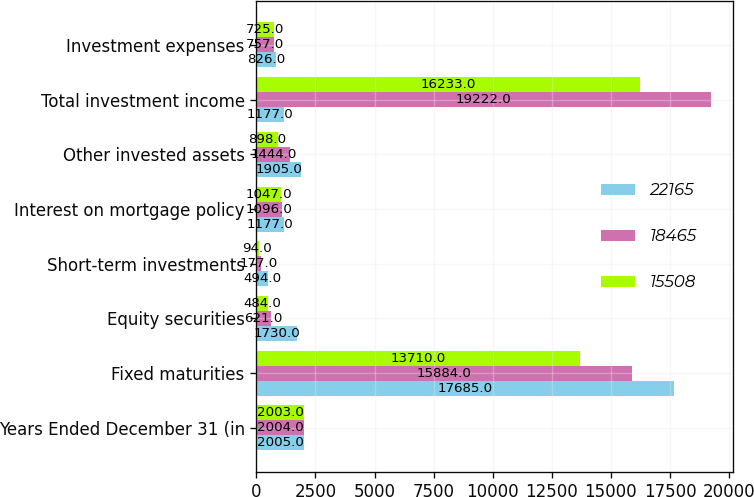Convert chart. <chart><loc_0><loc_0><loc_500><loc_500><stacked_bar_chart><ecel><fcel>Years Ended December 31 (in<fcel>Fixed maturities<fcel>Equity securities<fcel>Short-term investments<fcel>Interest on mortgage policy<fcel>Other invested assets<fcel>Total investment income<fcel>Investment expenses<nl><fcel>22165<fcel>2005<fcel>17685<fcel>1730<fcel>494<fcel>1177<fcel>1905<fcel>1177<fcel>826<nl><fcel>18465<fcel>2004<fcel>15884<fcel>621<fcel>177<fcel>1096<fcel>1444<fcel>19222<fcel>757<nl><fcel>15508<fcel>2003<fcel>13710<fcel>484<fcel>94<fcel>1047<fcel>898<fcel>16233<fcel>725<nl></chart> 